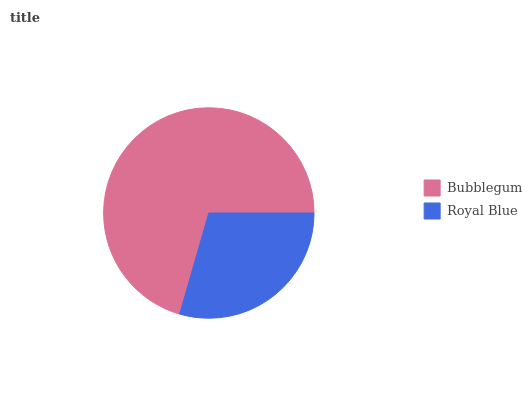Is Royal Blue the minimum?
Answer yes or no. Yes. Is Bubblegum the maximum?
Answer yes or no. Yes. Is Royal Blue the maximum?
Answer yes or no. No. Is Bubblegum greater than Royal Blue?
Answer yes or no. Yes. Is Royal Blue less than Bubblegum?
Answer yes or no. Yes. Is Royal Blue greater than Bubblegum?
Answer yes or no. No. Is Bubblegum less than Royal Blue?
Answer yes or no. No. Is Bubblegum the high median?
Answer yes or no. Yes. Is Royal Blue the low median?
Answer yes or no. Yes. Is Royal Blue the high median?
Answer yes or no. No. Is Bubblegum the low median?
Answer yes or no. No. 